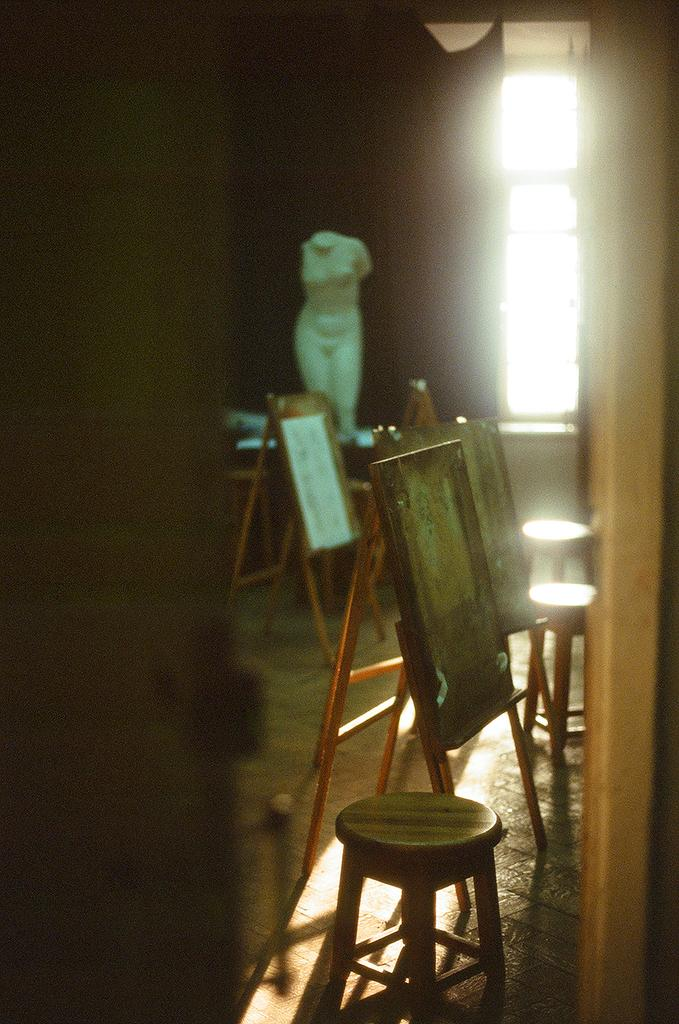What type of furniture is present in the image? There are stools in the image. What else can be seen in the image besides the stools? There are boards and a statue on the floor in the image. What architectural feature is visible in the image? There is a window in the image. How would you describe the lighting in the image? The background of the image is dark. Can you tell me how many animals are in the zoo in the image? There is no zoo present in the image, so it is not possible to determine how many animals might be there. Who is the expert in the image? There is no expert present in the image; it features stools, boards, a statue, a window, and a dark background. 